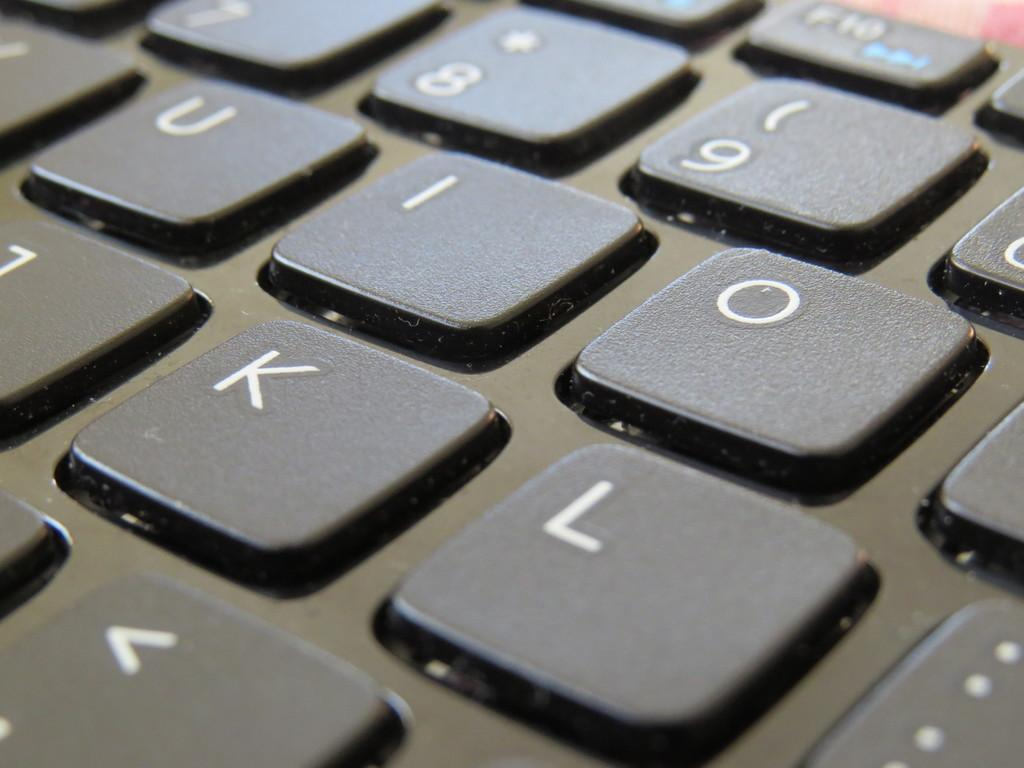<image>
Create a compact narrative representing the image presented. A closeup showing the 8,9, I, O, K and L keys on a keyboard. 